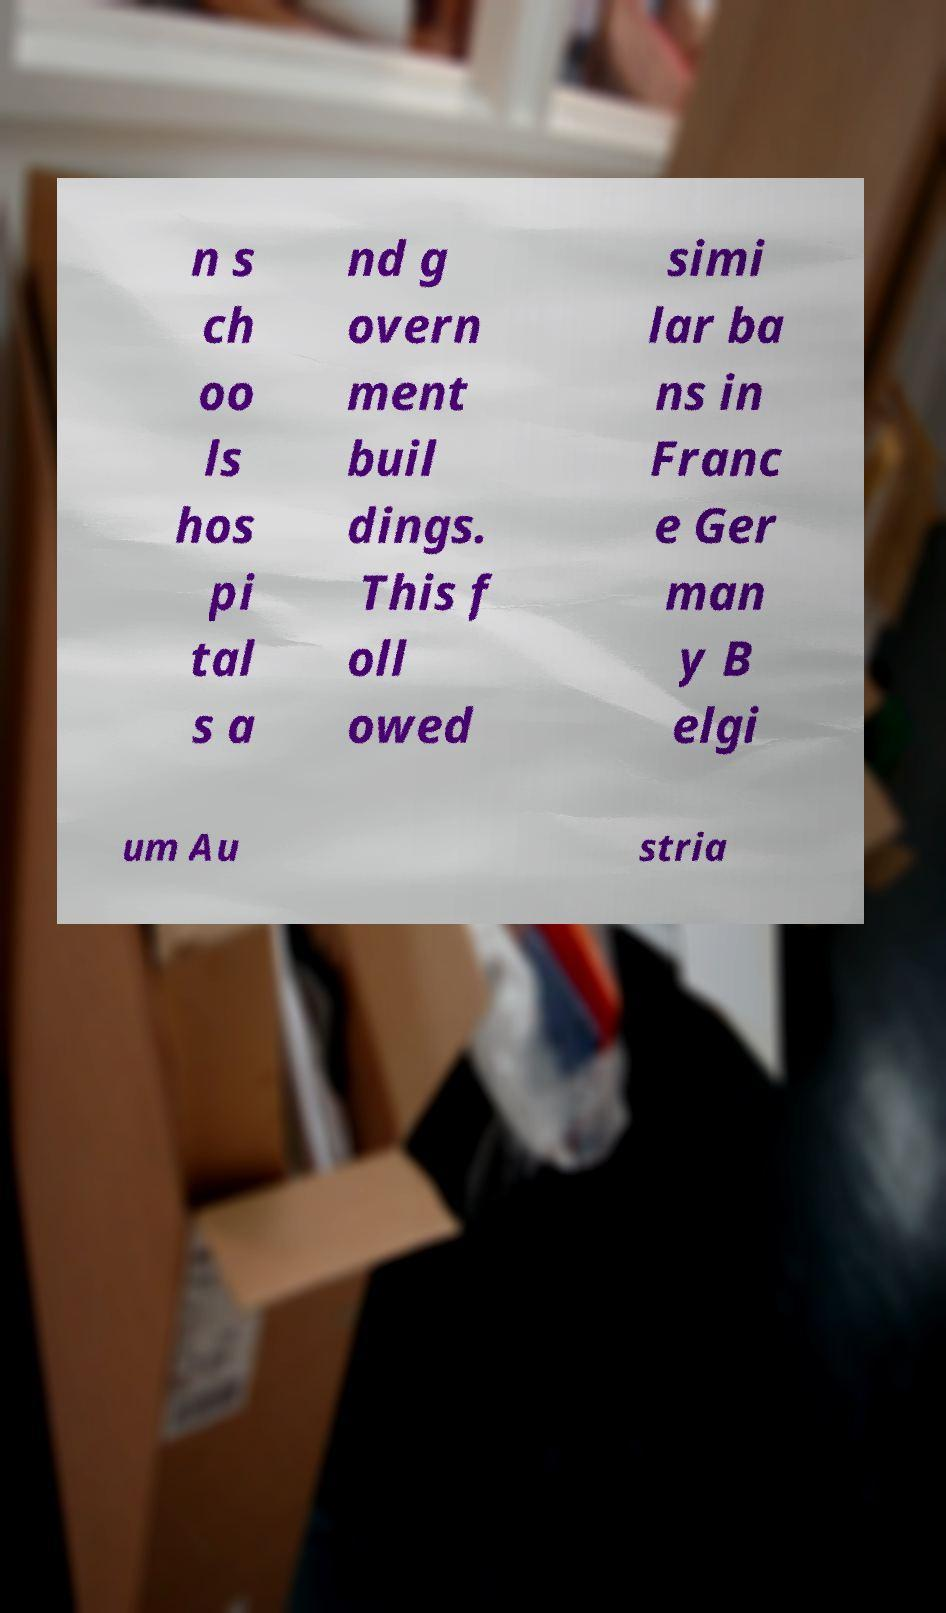Please read and relay the text visible in this image. What does it say? n s ch oo ls hos pi tal s a nd g overn ment buil dings. This f oll owed simi lar ba ns in Franc e Ger man y B elgi um Au stria 